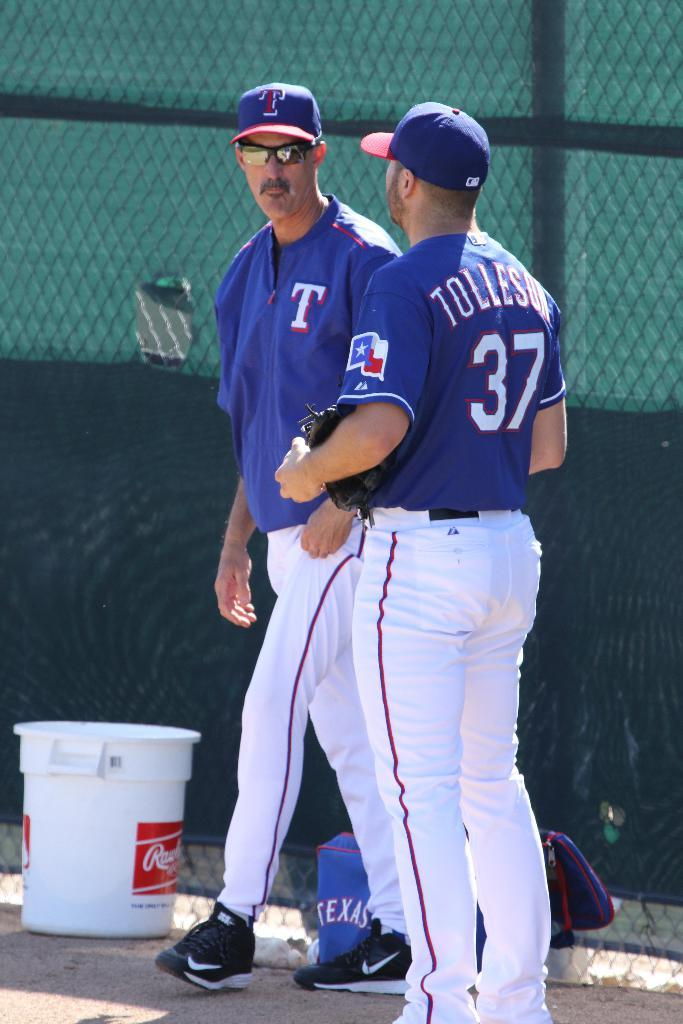<image>
Give a short and clear explanation of the subsequent image. The man's shirt has the number thirty-seven on the back. 